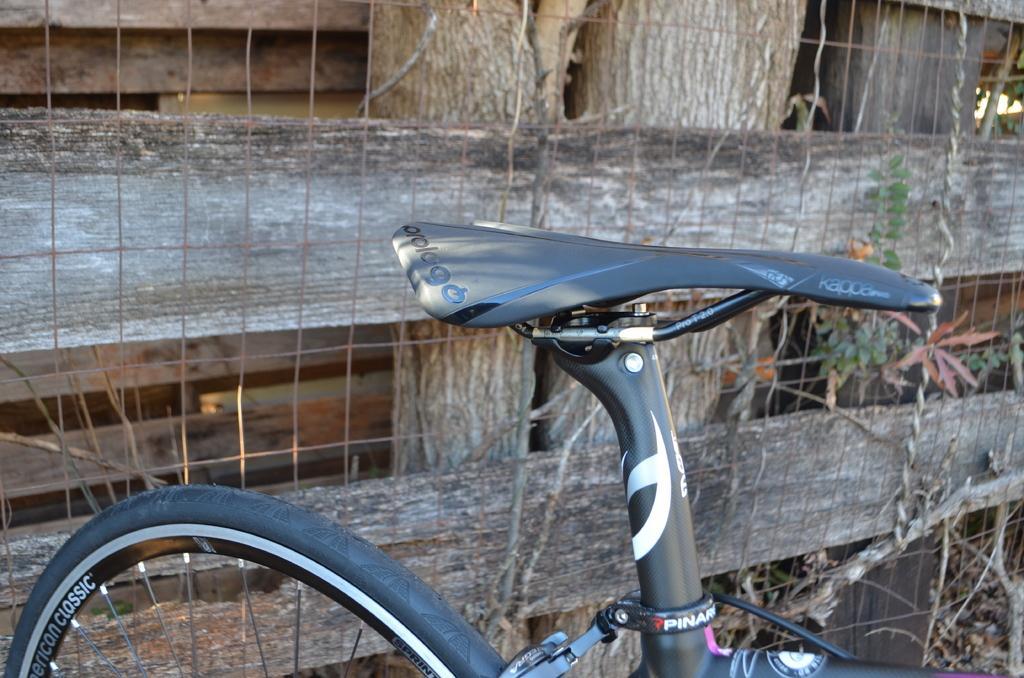Describe this image in one or two sentences. In this picture we can see a bicycle. Behind the bicycle, there are tree trunks, wire fence, wooden objects and plants. 